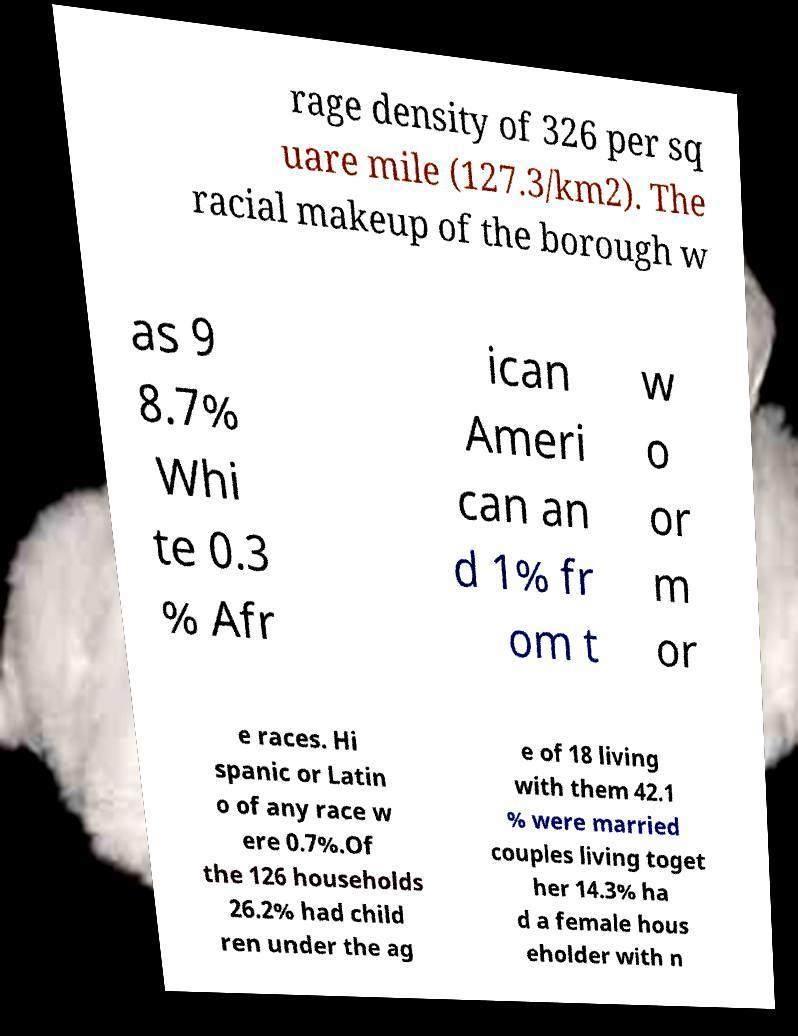Please identify and transcribe the text found in this image. rage density of 326 per sq uare mile (127.3/km2). The racial makeup of the borough w as 9 8.7% Whi te 0.3 % Afr ican Ameri can an d 1% fr om t w o or m or e races. Hi spanic or Latin o of any race w ere 0.7%.Of the 126 households 26.2% had child ren under the ag e of 18 living with them 42.1 % were married couples living toget her 14.3% ha d a female hous eholder with n 